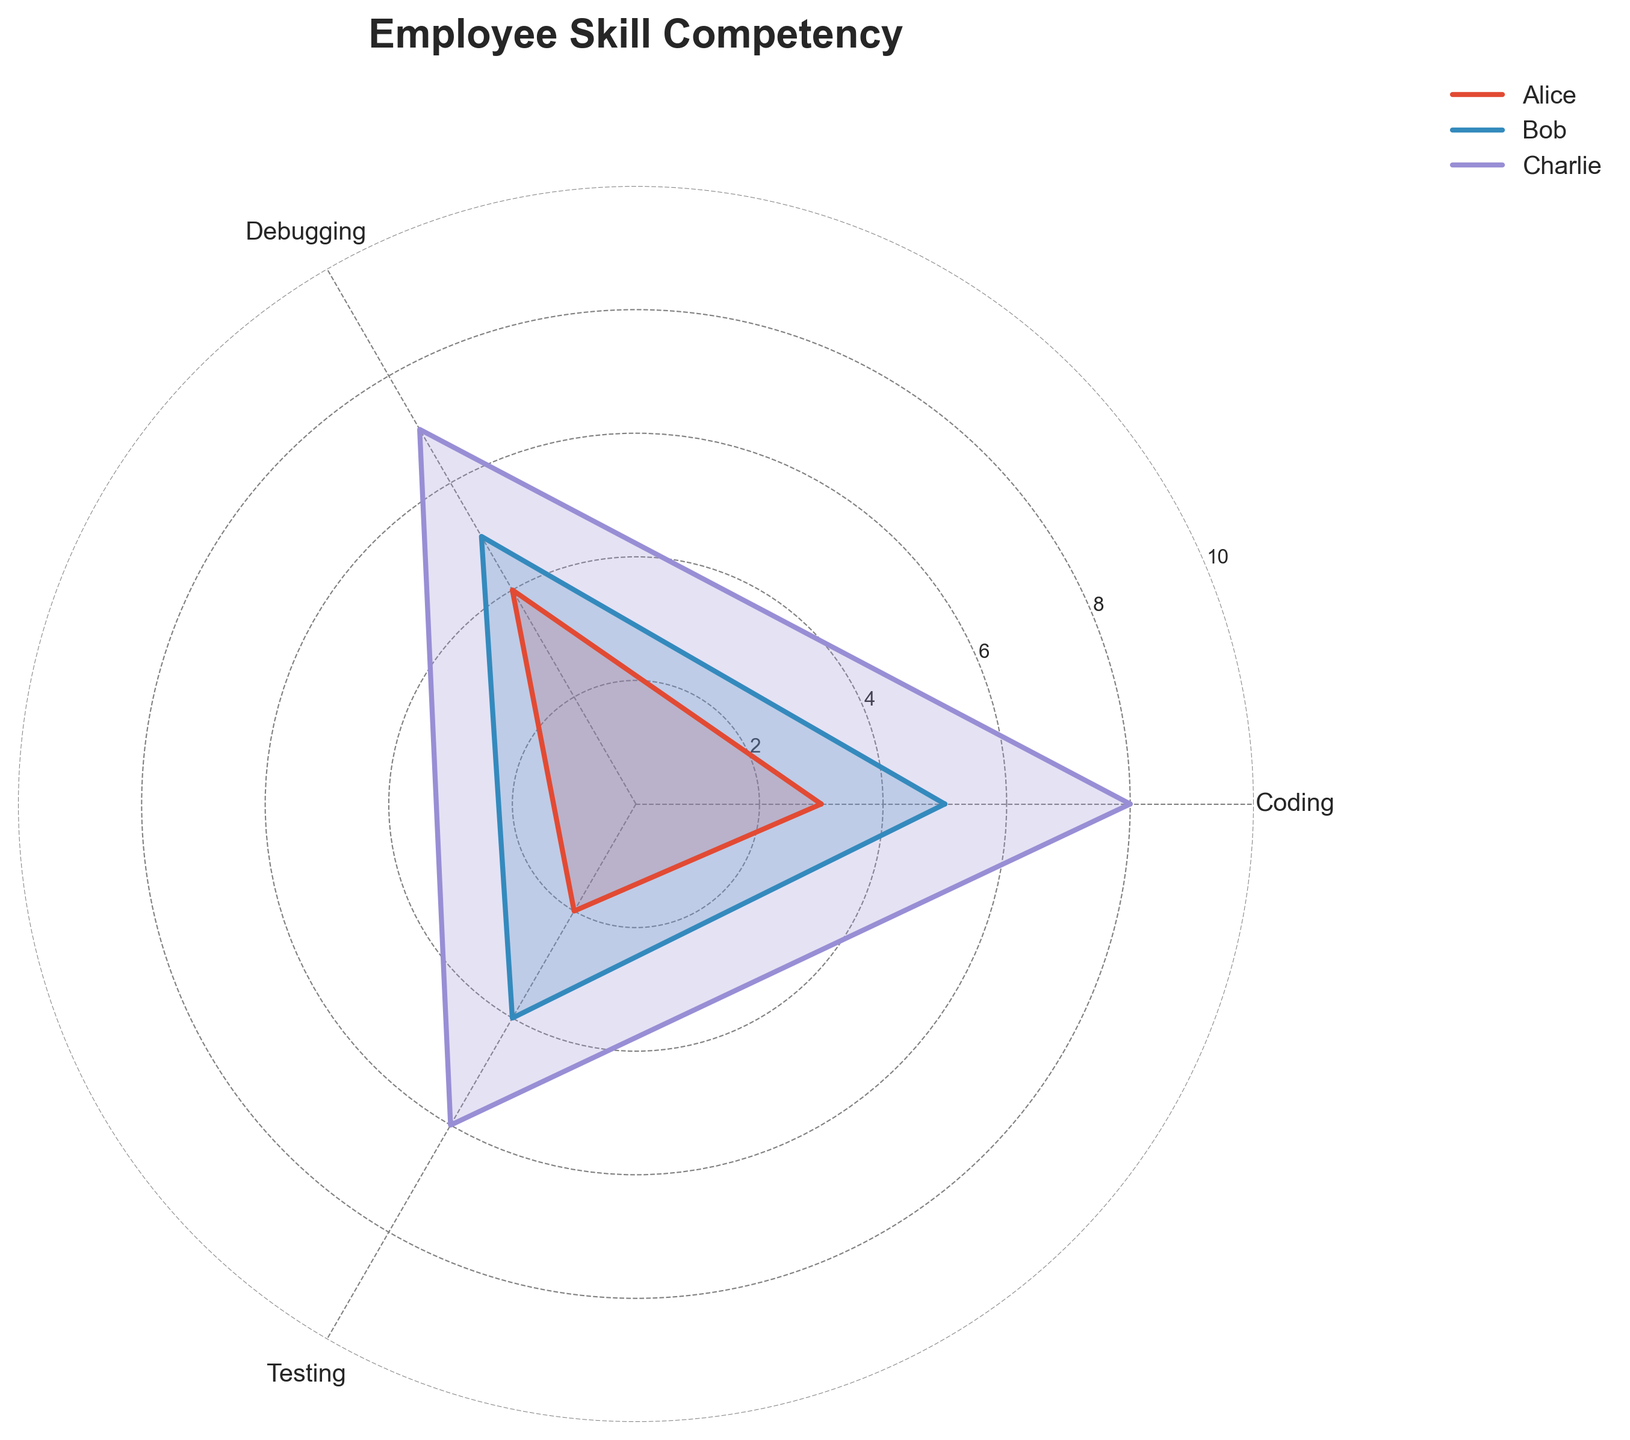who are the three employees shown in the radar chart? By looking at the labels or legend of the radar chart, you can identify the names of the employees. There are only three employees shown in the radar chart as per the instructions.
Answer: Alice, Bob, Charlie Which skill category is in the middle on the radar chart? The middle skill category is the one that is positioned between the first and the last skill categories (leftmost and rightmost positions) in the axes of the radar chart. Typically, this would be the second skill listed in the `categories`.
Answer: Debugging What is the maximum level of expertise shown on the radar chart? By examining the y-axis or the radial lines of the radar chart, the maximum level of expertise can be identified as it is the highest value indicated.
Answer: 10 Comparing Alice and Bob, in which skill does Bob have a higher level of expertise? To determine which skill Bob has a higher level than Alice, visually compare the lengths of the respective data points along the axes for both Alice and Bob.
Answer: All skills What is the average expertise level in Testing for Alice, Bob, and Charlie? The average expertise level can be calculated by adding the Testing levels for Alice, Bob, and Charlie and dividing by the number of individuals, which is 3. So, (2 + 4 + 6) / 3.
Answer: 4 In which skill does Charlie have the highest competence? By examining Charlie's data points, identify which skill's axis has the maximum length. This is the highest point in the radar chart for Charlie.
Answer: Coding Rank the employees based on their Debugging skills from highest to lowest. By comparing the values on the Debugging axis, the ranking from the highest to lowest competency can be determined. Charlie: 7, Bob: 5, Alice: 4.
Answer: Charlie > Bob > Alice Which employee exhibits the most balanced expertise across all three skills? The most balanced expertise can be deduced by identifying the employee whose plot line forms the most circular shape, indicating more equal competency across all skill categories.
Answer: Bob If we consider the combined skills in Coding and Testing, who has the highest total score? The combined score can be calculated by summing the values of Coding and Testing skills for each employee and comparing these totals to determine the highest. For Alice: 3+2=5, Bob: 5+4=9, Charlie: 8+6=14.
Answer: Charlie 